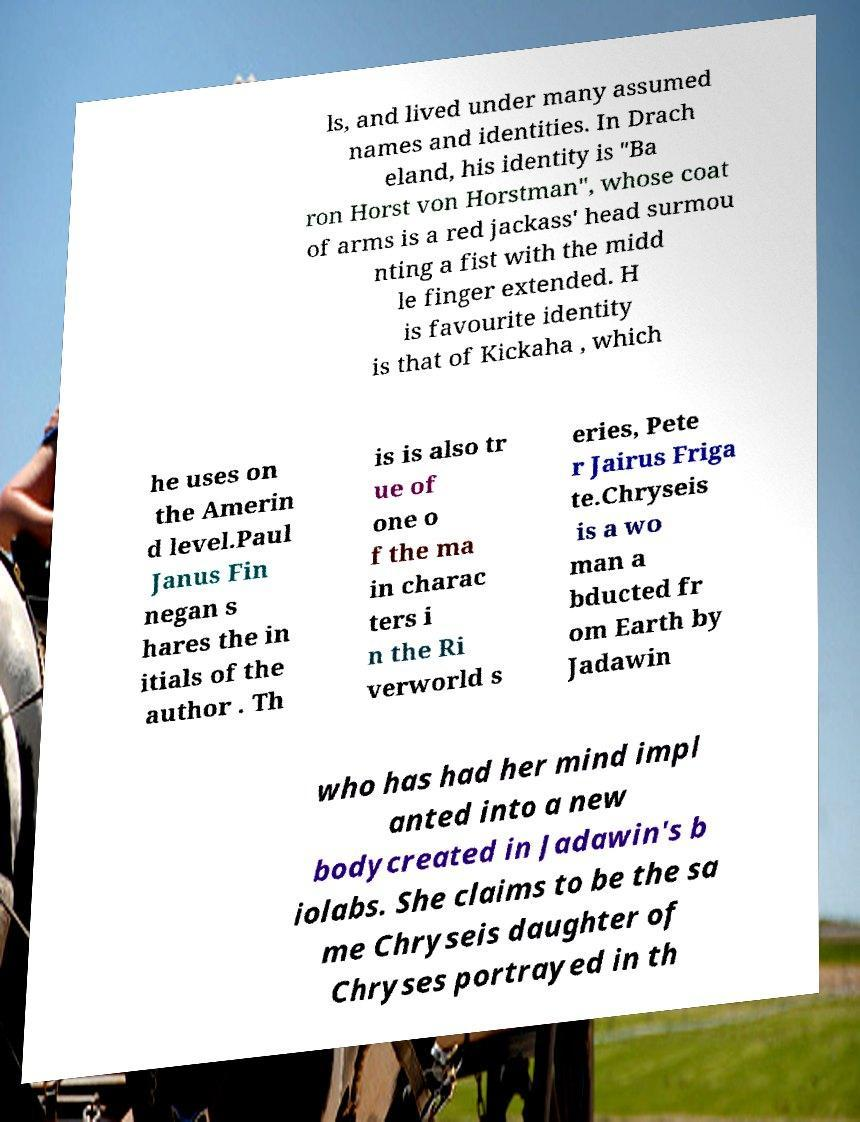Could you extract and type out the text from this image? ls, and lived under many assumed names and identities. In Drach eland, his identity is "Ba ron Horst von Horstman", whose coat of arms is a red jackass' head surmou nting a fist with the midd le finger extended. H is favourite identity is that of Kickaha , which he uses on the Amerin d level.Paul Janus Fin negan s hares the in itials of the author . Th is is also tr ue of one o f the ma in charac ters i n the Ri verworld s eries, Pete r Jairus Friga te.Chryseis is a wo man a bducted fr om Earth by Jadawin who has had her mind impl anted into a new bodycreated in Jadawin's b iolabs. She claims to be the sa me Chryseis daughter of Chryses portrayed in th 